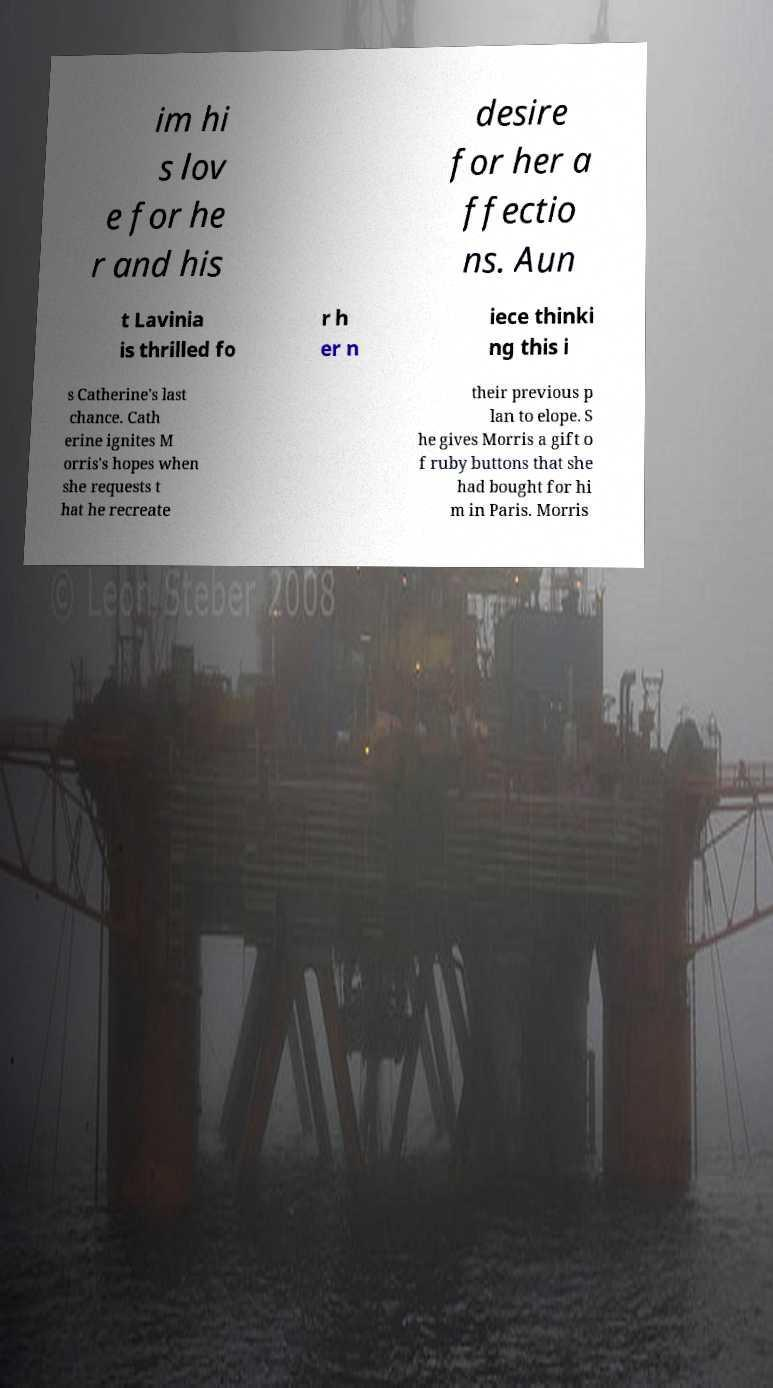For documentation purposes, I need the text within this image transcribed. Could you provide that? im hi s lov e for he r and his desire for her a ffectio ns. Aun t Lavinia is thrilled fo r h er n iece thinki ng this i s Catherine's last chance. Cath erine ignites M orris's hopes when she requests t hat he recreate their previous p lan to elope. S he gives Morris a gift o f ruby buttons that she had bought for hi m in Paris. Morris 